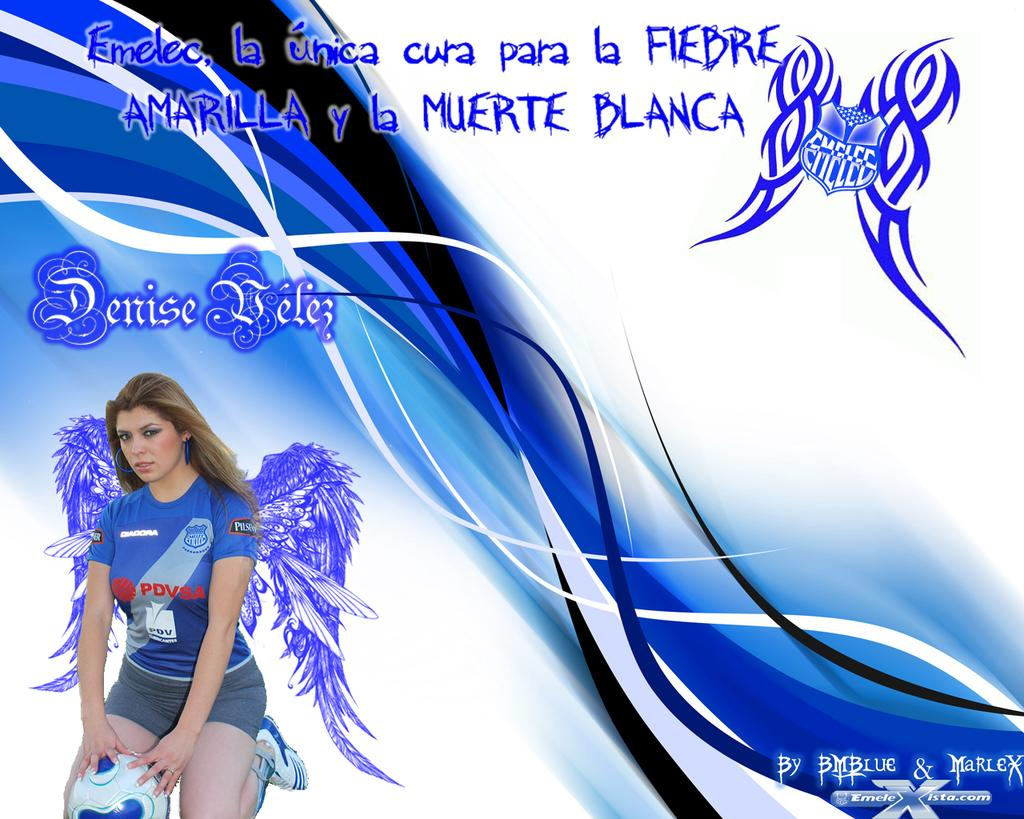<image>
Offer a succinct explanation of the picture presented. Poster showing a woman with wings and the words " Denise Belek" above. 